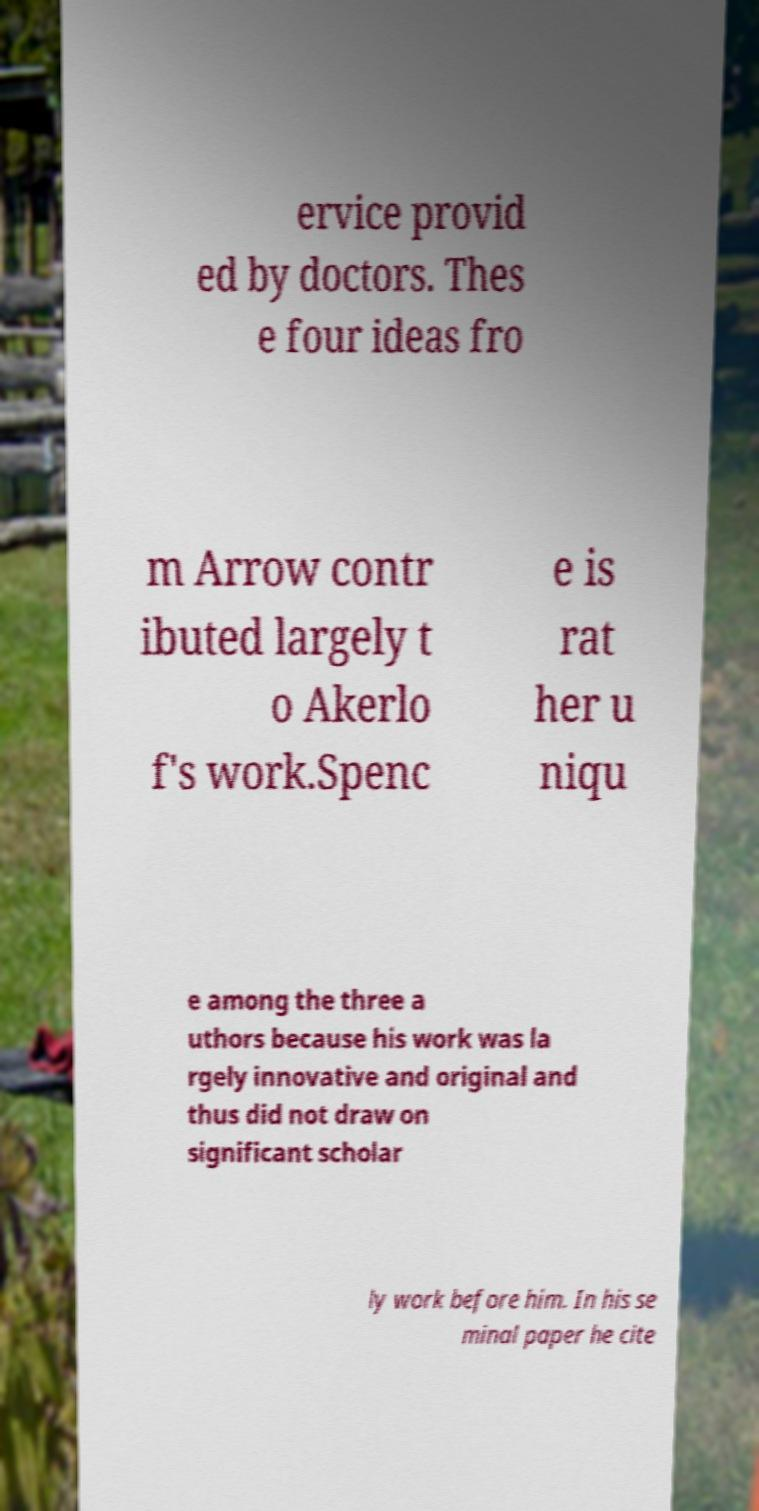Can you accurately transcribe the text from the provided image for me? ervice provid ed by doctors. Thes e four ideas fro m Arrow contr ibuted largely t o Akerlo f's work.Spenc e is rat her u niqu e among the three a uthors because his work was la rgely innovative and original and thus did not draw on significant scholar ly work before him. In his se minal paper he cite 